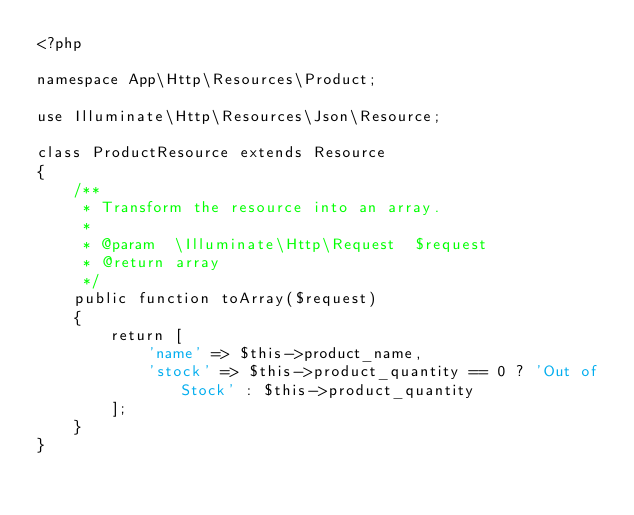Convert code to text. <code><loc_0><loc_0><loc_500><loc_500><_PHP_><?php

namespace App\Http\Resources\Product;

use Illuminate\Http\Resources\Json\Resource;

class ProductResource extends Resource
{
    /**
     * Transform the resource into an array.
     *
     * @param  \Illuminate\Http\Request  $request
     * @return array
     */
    public function toArray($request)
    {
        return [
            'name' => $this->product_name,
            'stock' => $this->product_quantity == 0 ? 'Out of Stock' : $this->product_quantity
        ];
    }
}
</code> 